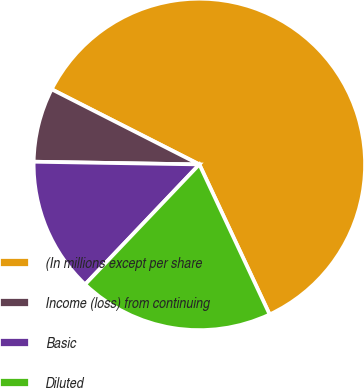Convert chart. <chart><loc_0><loc_0><loc_500><loc_500><pie_chart><fcel>(In millions except per share<fcel>Income (loss) from continuing<fcel>Basic<fcel>Diluted<nl><fcel>60.54%<fcel>7.23%<fcel>13.15%<fcel>19.08%<nl></chart> 